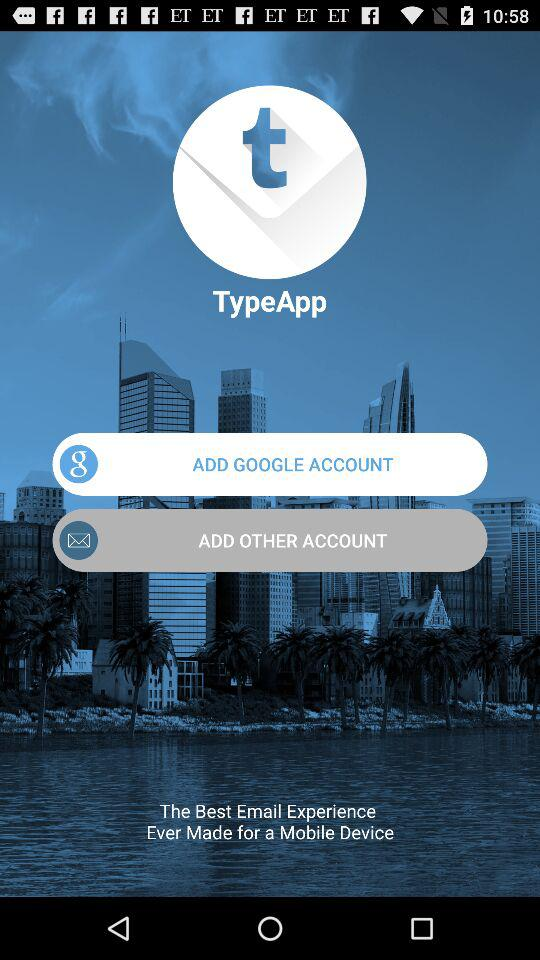What accounts can I use to sign up? You can use "GOOGLE" and "Email" accounts to sign up. 